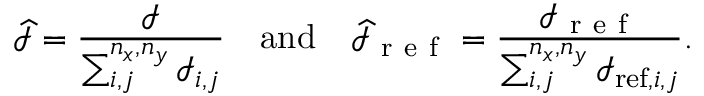<formula> <loc_0><loc_0><loc_500><loc_500>\widehat { \mathcal { I } } = \frac { \mathcal { I } } { \sum _ { i , j } ^ { n _ { x } , n _ { y } } \mathcal { I } _ { i , j } } \quad a n d \quad \widehat { \mathcal { I } } _ { r e f } = \frac { \mathcal { I } _ { r e f } } { \sum _ { i , j } ^ { n _ { x } , n _ { y } } \mathcal { I } _ { r e f , i , j } } .</formula> 